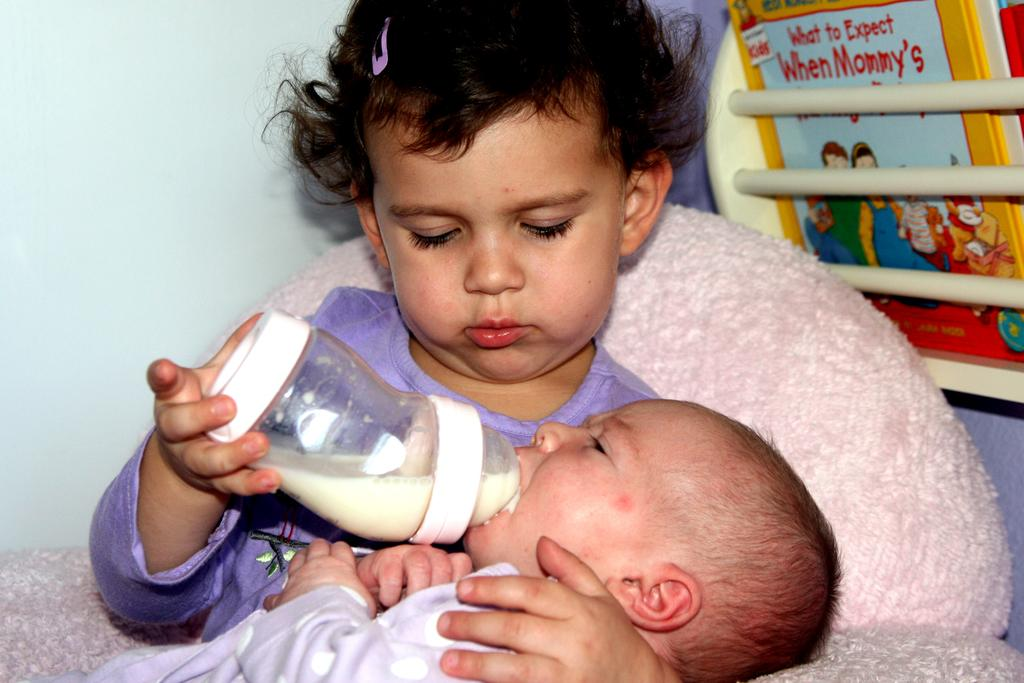How many children are in the image? There are two children in the image. What is in the bottle that is visible in the image? There is a bottle with milk in it. What can be seen in the background of the image? There is a wall, a book, and other objects visible in the background of the image. What type of yarn is the cub using to express its hate in the image? There is no cub or yarn present in the image, and no expression of hate can be observed. 